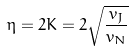<formula> <loc_0><loc_0><loc_500><loc_500>\eta = 2 K = 2 \sqrt { \frac { v _ { J } } { v _ { N } } }</formula> 